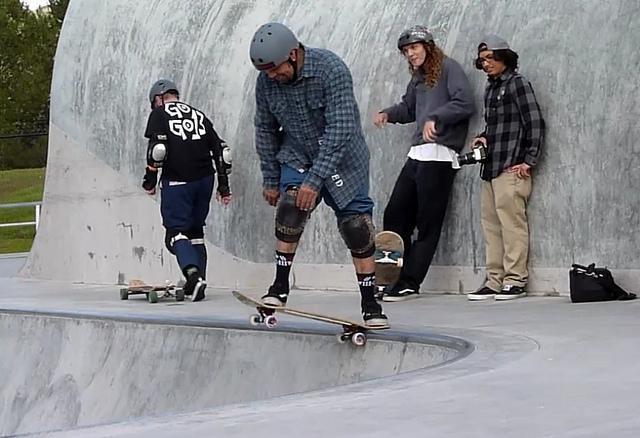How many people are leaning against the wall?
Give a very brief answer. 2. How many of them are wearing helmets?
Give a very brief answer. 3. How many skateboards are visible?
Give a very brief answer. 1. How many people are in the picture?
Give a very brief answer. 4. How many baby elephants statues on the left of the mother elephants ?
Give a very brief answer. 0. 